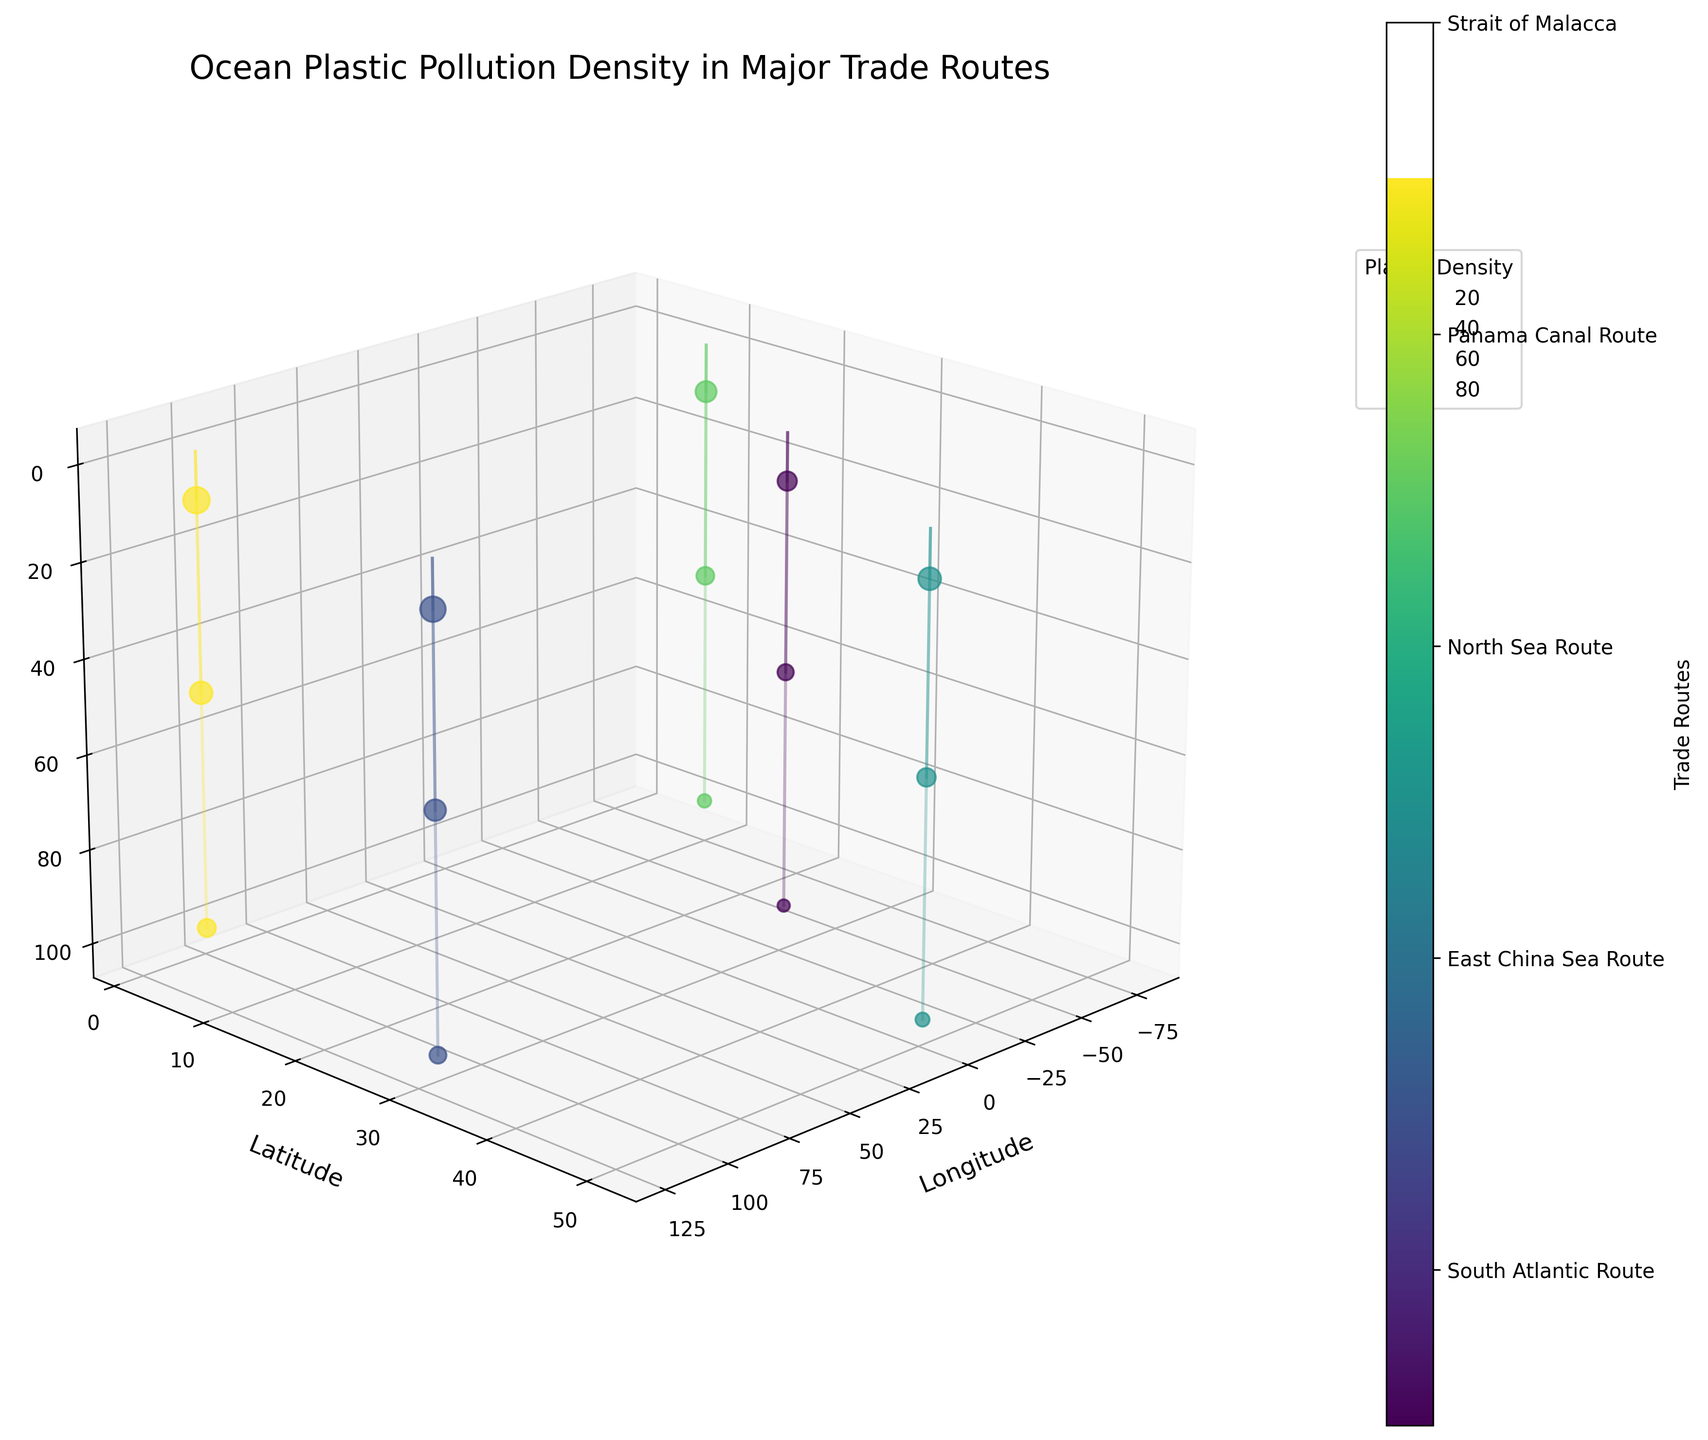What is the title of the figure? The title of the figure is at the top and provides an overall description of what the plot represents.
Answer: Ocean Plastic Pollution Density in Major Trade Routes Which trade route has the highest plastic density in shallow waters (10m depth)? By observing the largest bubble size at 10m depth for each route, the Strait of Malacca has the highest plastic density.
Answer: Strait of Malacca Which route shows the least plastic density at a depth of 100m? The smallest bubble size at 100m depth is used for comparison across routes. The South Atlantic Route has the smallest bubble.
Answer: South Atlantic Route How many trade routes are represented in the plot? The color bar legend to the right lists all unique trade routes represented in the plot, totaling five.
Answer: 5 What is the plastic density at 50m depth for the North Sea Route? By locating the bubble at the specified depth for the North Sea Route, the plastic density value can be identified directly from its size.
Answer: 41.8 Which route has consistently high plastic pollution at all depths observed? By examining each route's plastic density across multiple depths, the Strait of Malacca consistently shows high plastic density at 10m, 50m, and 100m depths.
Answer: Strait of Malacca How do plastic densities at 10m depth in the East China Sea Route compare to the Panama Canal Route? Comparing the sizes of the bubbles representing 10m depth for both routes, the East China Sea Route has a larger bubble and therefore higher plastic density than the Panama Canal Route.
Answer: East China Sea Route has higher density What is the average plastic density at 100m depth across all routes? Summing up the plastic densities at 100m depth for all routes (18.6 + 34.7 + 23.9 + 22.1 + 39.5) and dividing by the number of routes (5) provides the average.
Answer: 27.76 Between which depths does the South Atlantic Route show the largest decrease in plastic density? Subtract the plastic density at 50m and 100m from that at 10m, and compare the differences: (45.3-32.1) = 13.2 and (32.1-18.6) = 13.5; the largest decrease is between 50m and 100m.
Answer: 50m and 100m Which axis represents the depth in the plot? Observing the label on the third dimension, the depth is represented on the Z-axis.
Answer: Z-axis 